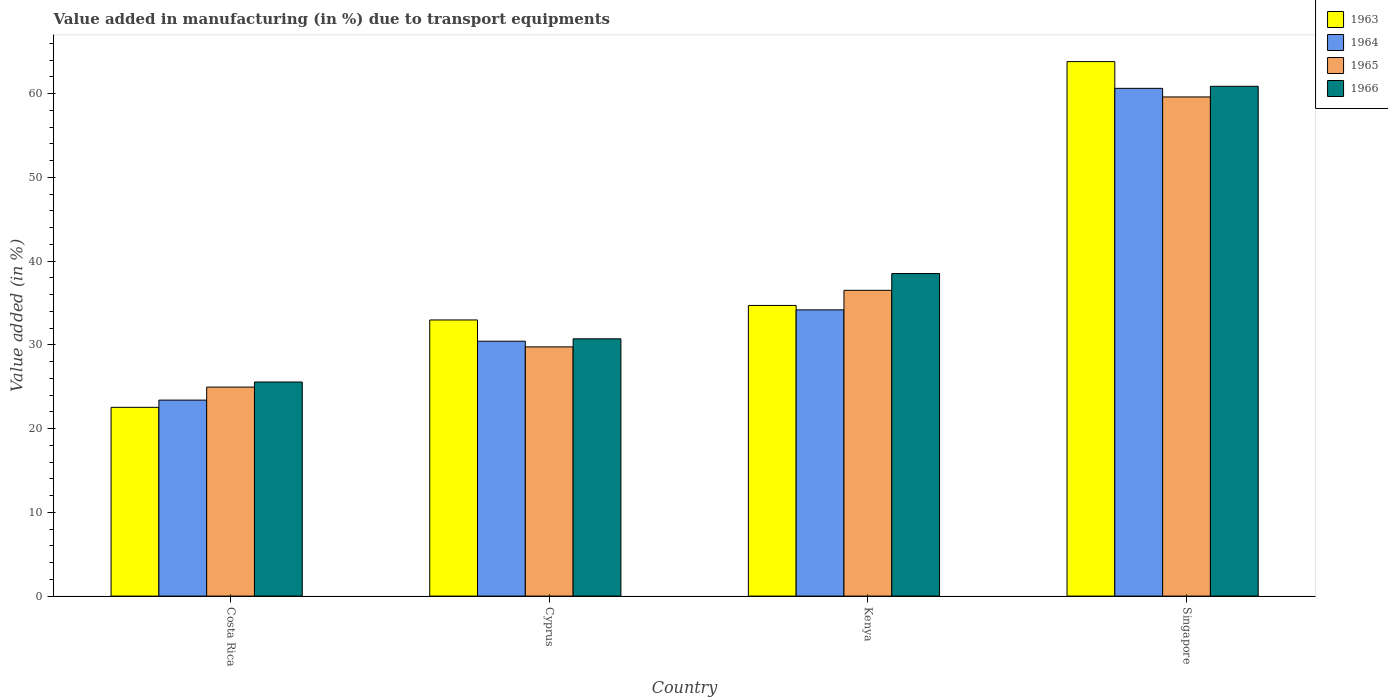How many groups of bars are there?
Make the answer very short. 4. Are the number of bars per tick equal to the number of legend labels?
Offer a terse response. Yes. Are the number of bars on each tick of the X-axis equal?
Offer a terse response. Yes. How many bars are there on the 1st tick from the left?
Your answer should be very brief. 4. What is the label of the 1st group of bars from the left?
Keep it short and to the point. Costa Rica. What is the percentage of value added in manufacturing due to transport equipments in 1964 in Costa Rica?
Offer a very short reply. 23.4. Across all countries, what is the maximum percentage of value added in manufacturing due to transport equipments in 1964?
Your answer should be very brief. 60.62. Across all countries, what is the minimum percentage of value added in manufacturing due to transport equipments in 1965?
Keep it short and to the point. 24.95. In which country was the percentage of value added in manufacturing due to transport equipments in 1965 maximum?
Offer a very short reply. Singapore. In which country was the percentage of value added in manufacturing due to transport equipments in 1966 minimum?
Give a very brief answer. Costa Rica. What is the total percentage of value added in manufacturing due to transport equipments in 1963 in the graph?
Your response must be concise. 154.01. What is the difference between the percentage of value added in manufacturing due to transport equipments in 1965 in Kenya and that in Singapore?
Give a very brief answer. -23.09. What is the difference between the percentage of value added in manufacturing due to transport equipments in 1964 in Cyprus and the percentage of value added in manufacturing due to transport equipments in 1966 in Costa Rica?
Provide a short and direct response. 4.87. What is the average percentage of value added in manufacturing due to transport equipments in 1965 per country?
Ensure brevity in your answer.  37.7. What is the difference between the percentage of value added in manufacturing due to transport equipments of/in 1965 and percentage of value added in manufacturing due to transport equipments of/in 1963 in Kenya?
Make the answer very short. 1.8. In how many countries, is the percentage of value added in manufacturing due to transport equipments in 1964 greater than 18 %?
Your answer should be compact. 4. What is the ratio of the percentage of value added in manufacturing due to transport equipments in 1965 in Cyprus to that in Kenya?
Make the answer very short. 0.82. Is the difference between the percentage of value added in manufacturing due to transport equipments in 1965 in Cyprus and Kenya greater than the difference between the percentage of value added in manufacturing due to transport equipments in 1963 in Cyprus and Kenya?
Make the answer very short. No. What is the difference between the highest and the second highest percentage of value added in manufacturing due to transport equipments in 1966?
Make the answer very short. 22.35. What is the difference between the highest and the lowest percentage of value added in manufacturing due to transport equipments in 1966?
Provide a short and direct response. 35.3. In how many countries, is the percentage of value added in manufacturing due to transport equipments in 1965 greater than the average percentage of value added in manufacturing due to transport equipments in 1965 taken over all countries?
Provide a short and direct response. 1. Is the sum of the percentage of value added in manufacturing due to transport equipments in 1963 in Costa Rica and Cyprus greater than the maximum percentage of value added in manufacturing due to transport equipments in 1964 across all countries?
Ensure brevity in your answer.  No. What does the 4th bar from the left in Kenya represents?
Your answer should be compact. 1966. What does the 3rd bar from the right in Costa Rica represents?
Your response must be concise. 1964. Is it the case that in every country, the sum of the percentage of value added in manufacturing due to transport equipments in 1963 and percentage of value added in manufacturing due to transport equipments in 1965 is greater than the percentage of value added in manufacturing due to transport equipments in 1964?
Provide a succinct answer. Yes. Are all the bars in the graph horizontal?
Offer a very short reply. No. Does the graph contain any zero values?
Ensure brevity in your answer.  No. Where does the legend appear in the graph?
Make the answer very short. Top right. How many legend labels are there?
Give a very brief answer. 4. How are the legend labels stacked?
Make the answer very short. Vertical. What is the title of the graph?
Keep it short and to the point. Value added in manufacturing (in %) due to transport equipments. What is the label or title of the X-axis?
Keep it short and to the point. Country. What is the label or title of the Y-axis?
Offer a very short reply. Value added (in %). What is the Value added (in %) in 1963 in Costa Rica?
Make the answer very short. 22.53. What is the Value added (in %) of 1964 in Costa Rica?
Provide a succinct answer. 23.4. What is the Value added (in %) in 1965 in Costa Rica?
Keep it short and to the point. 24.95. What is the Value added (in %) in 1966 in Costa Rica?
Your response must be concise. 25.56. What is the Value added (in %) in 1963 in Cyprus?
Your response must be concise. 32.97. What is the Value added (in %) of 1964 in Cyprus?
Make the answer very short. 30.43. What is the Value added (in %) of 1965 in Cyprus?
Provide a succinct answer. 29.75. What is the Value added (in %) in 1966 in Cyprus?
Ensure brevity in your answer.  30.72. What is the Value added (in %) of 1963 in Kenya?
Ensure brevity in your answer.  34.7. What is the Value added (in %) in 1964 in Kenya?
Your answer should be very brief. 34.17. What is the Value added (in %) in 1965 in Kenya?
Your answer should be very brief. 36.5. What is the Value added (in %) in 1966 in Kenya?
Your answer should be very brief. 38.51. What is the Value added (in %) of 1963 in Singapore?
Provide a short and direct response. 63.81. What is the Value added (in %) of 1964 in Singapore?
Offer a terse response. 60.62. What is the Value added (in %) in 1965 in Singapore?
Your answer should be very brief. 59.59. What is the Value added (in %) of 1966 in Singapore?
Keep it short and to the point. 60.86. Across all countries, what is the maximum Value added (in %) in 1963?
Your answer should be very brief. 63.81. Across all countries, what is the maximum Value added (in %) of 1964?
Your answer should be very brief. 60.62. Across all countries, what is the maximum Value added (in %) of 1965?
Your response must be concise. 59.59. Across all countries, what is the maximum Value added (in %) in 1966?
Provide a short and direct response. 60.86. Across all countries, what is the minimum Value added (in %) in 1963?
Make the answer very short. 22.53. Across all countries, what is the minimum Value added (in %) in 1964?
Keep it short and to the point. 23.4. Across all countries, what is the minimum Value added (in %) of 1965?
Offer a terse response. 24.95. Across all countries, what is the minimum Value added (in %) in 1966?
Offer a very short reply. 25.56. What is the total Value added (in %) of 1963 in the graph?
Offer a terse response. 154.01. What is the total Value added (in %) in 1964 in the graph?
Ensure brevity in your answer.  148.61. What is the total Value added (in %) of 1965 in the graph?
Your answer should be compact. 150.8. What is the total Value added (in %) in 1966 in the graph?
Ensure brevity in your answer.  155.64. What is the difference between the Value added (in %) in 1963 in Costa Rica and that in Cyprus?
Offer a terse response. -10.43. What is the difference between the Value added (in %) of 1964 in Costa Rica and that in Cyprus?
Provide a short and direct response. -7.03. What is the difference between the Value added (in %) in 1965 in Costa Rica and that in Cyprus?
Provide a succinct answer. -4.8. What is the difference between the Value added (in %) of 1966 in Costa Rica and that in Cyprus?
Your response must be concise. -5.16. What is the difference between the Value added (in %) in 1963 in Costa Rica and that in Kenya?
Provide a succinct answer. -12.17. What is the difference between the Value added (in %) in 1964 in Costa Rica and that in Kenya?
Offer a terse response. -10.77. What is the difference between the Value added (in %) in 1965 in Costa Rica and that in Kenya?
Your answer should be compact. -11.55. What is the difference between the Value added (in %) in 1966 in Costa Rica and that in Kenya?
Your answer should be very brief. -12.95. What is the difference between the Value added (in %) of 1963 in Costa Rica and that in Singapore?
Your answer should be very brief. -41.28. What is the difference between the Value added (in %) in 1964 in Costa Rica and that in Singapore?
Keep it short and to the point. -37.22. What is the difference between the Value added (in %) in 1965 in Costa Rica and that in Singapore?
Your response must be concise. -34.64. What is the difference between the Value added (in %) of 1966 in Costa Rica and that in Singapore?
Give a very brief answer. -35.3. What is the difference between the Value added (in %) in 1963 in Cyprus and that in Kenya?
Offer a terse response. -1.73. What is the difference between the Value added (in %) of 1964 in Cyprus and that in Kenya?
Give a very brief answer. -3.74. What is the difference between the Value added (in %) of 1965 in Cyprus and that in Kenya?
Keep it short and to the point. -6.75. What is the difference between the Value added (in %) in 1966 in Cyprus and that in Kenya?
Ensure brevity in your answer.  -7.79. What is the difference between the Value added (in %) of 1963 in Cyprus and that in Singapore?
Make the answer very short. -30.84. What is the difference between the Value added (in %) in 1964 in Cyprus and that in Singapore?
Your answer should be compact. -30.19. What is the difference between the Value added (in %) of 1965 in Cyprus and that in Singapore?
Give a very brief answer. -29.84. What is the difference between the Value added (in %) of 1966 in Cyprus and that in Singapore?
Keep it short and to the point. -30.14. What is the difference between the Value added (in %) in 1963 in Kenya and that in Singapore?
Keep it short and to the point. -29.11. What is the difference between the Value added (in %) in 1964 in Kenya and that in Singapore?
Keep it short and to the point. -26.45. What is the difference between the Value added (in %) in 1965 in Kenya and that in Singapore?
Your response must be concise. -23.09. What is the difference between the Value added (in %) of 1966 in Kenya and that in Singapore?
Offer a very short reply. -22.35. What is the difference between the Value added (in %) in 1963 in Costa Rica and the Value added (in %) in 1964 in Cyprus?
Offer a very short reply. -7.9. What is the difference between the Value added (in %) of 1963 in Costa Rica and the Value added (in %) of 1965 in Cyprus?
Provide a succinct answer. -7.22. What is the difference between the Value added (in %) of 1963 in Costa Rica and the Value added (in %) of 1966 in Cyprus?
Ensure brevity in your answer.  -8.18. What is the difference between the Value added (in %) of 1964 in Costa Rica and the Value added (in %) of 1965 in Cyprus?
Your answer should be compact. -6.36. What is the difference between the Value added (in %) in 1964 in Costa Rica and the Value added (in %) in 1966 in Cyprus?
Keep it short and to the point. -7.32. What is the difference between the Value added (in %) of 1965 in Costa Rica and the Value added (in %) of 1966 in Cyprus?
Provide a succinct answer. -5.77. What is the difference between the Value added (in %) in 1963 in Costa Rica and the Value added (in %) in 1964 in Kenya?
Give a very brief answer. -11.64. What is the difference between the Value added (in %) in 1963 in Costa Rica and the Value added (in %) in 1965 in Kenya?
Keep it short and to the point. -13.97. What is the difference between the Value added (in %) of 1963 in Costa Rica and the Value added (in %) of 1966 in Kenya?
Ensure brevity in your answer.  -15.97. What is the difference between the Value added (in %) in 1964 in Costa Rica and the Value added (in %) in 1965 in Kenya?
Keep it short and to the point. -13.11. What is the difference between the Value added (in %) in 1964 in Costa Rica and the Value added (in %) in 1966 in Kenya?
Offer a very short reply. -15.11. What is the difference between the Value added (in %) of 1965 in Costa Rica and the Value added (in %) of 1966 in Kenya?
Offer a terse response. -13.56. What is the difference between the Value added (in %) in 1963 in Costa Rica and the Value added (in %) in 1964 in Singapore?
Give a very brief answer. -38.08. What is the difference between the Value added (in %) of 1963 in Costa Rica and the Value added (in %) of 1965 in Singapore?
Give a very brief answer. -37.06. What is the difference between the Value added (in %) of 1963 in Costa Rica and the Value added (in %) of 1966 in Singapore?
Provide a short and direct response. -38.33. What is the difference between the Value added (in %) in 1964 in Costa Rica and the Value added (in %) in 1965 in Singapore?
Your answer should be very brief. -36.19. What is the difference between the Value added (in %) of 1964 in Costa Rica and the Value added (in %) of 1966 in Singapore?
Keep it short and to the point. -37.46. What is the difference between the Value added (in %) of 1965 in Costa Rica and the Value added (in %) of 1966 in Singapore?
Ensure brevity in your answer.  -35.91. What is the difference between the Value added (in %) of 1963 in Cyprus and the Value added (in %) of 1964 in Kenya?
Give a very brief answer. -1.2. What is the difference between the Value added (in %) in 1963 in Cyprus and the Value added (in %) in 1965 in Kenya?
Keep it short and to the point. -3.54. What is the difference between the Value added (in %) in 1963 in Cyprus and the Value added (in %) in 1966 in Kenya?
Ensure brevity in your answer.  -5.54. What is the difference between the Value added (in %) in 1964 in Cyprus and the Value added (in %) in 1965 in Kenya?
Your answer should be compact. -6.07. What is the difference between the Value added (in %) in 1964 in Cyprus and the Value added (in %) in 1966 in Kenya?
Your answer should be very brief. -8.08. What is the difference between the Value added (in %) in 1965 in Cyprus and the Value added (in %) in 1966 in Kenya?
Your answer should be very brief. -8.75. What is the difference between the Value added (in %) in 1963 in Cyprus and the Value added (in %) in 1964 in Singapore?
Make the answer very short. -27.65. What is the difference between the Value added (in %) of 1963 in Cyprus and the Value added (in %) of 1965 in Singapore?
Ensure brevity in your answer.  -26.62. What is the difference between the Value added (in %) in 1963 in Cyprus and the Value added (in %) in 1966 in Singapore?
Ensure brevity in your answer.  -27.89. What is the difference between the Value added (in %) in 1964 in Cyprus and the Value added (in %) in 1965 in Singapore?
Keep it short and to the point. -29.16. What is the difference between the Value added (in %) of 1964 in Cyprus and the Value added (in %) of 1966 in Singapore?
Ensure brevity in your answer.  -30.43. What is the difference between the Value added (in %) of 1965 in Cyprus and the Value added (in %) of 1966 in Singapore?
Provide a short and direct response. -31.11. What is the difference between the Value added (in %) of 1963 in Kenya and the Value added (in %) of 1964 in Singapore?
Keep it short and to the point. -25.92. What is the difference between the Value added (in %) of 1963 in Kenya and the Value added (in %) of 1965 in Singapore?
Provide a short and direct response. -24.89. What is the difference between the Value added (in %) of 1963 in Kenya and the Value added (in %) of 1966 in Singapore?
Give a very brief answer. -26.16. What is the difference between the Value added (in %) of 1964 in Kenya and the Value added (in %) of 1965 in Singapore?
Provide a succinct answer. -25.42. What is the difference between the Value added (in %) in 1964 in Kenya and the Value added (in %) in 1966 in Singapore?
Give a very brief answer. -26.69. What is the difference between the Value added (in %) of 1965 in Kenya and the Value added (in %) of 1966 in Singapore?
Keep it short and to the point. -24.36. What is the average Value added (in %) in 1963 per country?
Your response must be concise. 38.5. What is the average Value added (in %) of 1964 per country?
Ensure brevity in your answer.  37.15. What is the average Value added (in %) in 1965 per country?
Ensure brevity in your answer.  37.7. What is the average Value added (in %) in 1966 per country?
Offer a terse response. 38.91. What is the difference between the Value added (in %) of 1963 and Value added (in %) of 1964 in Costa Rica?
Make the answer very short. -0.86. What is the difference between the Value added (in %) of 1963 and Value added (in %) of 1965 in Costa Rica?
Your response must be concise. -2.42. What is the difference between the Value added (in %) in 1963 and Value added (in %) in 1966 in Costa Rica?
Make the answer very short. -3.03. What is the difference between the Value added (in %) in 1964 and Value added (in %) in 1965 in Costa Rica?
Give a very brief answer. -1.55. What is the difference between the Value added (in %) of 1964 and Value added (in %) of 1966 in Costa Rica?
Provide a short and direct response. -2.16. What is the difference between the Value added (in %) in 1965 and Value added (in %) in 1966 in Costa Rica?
Your answer should be very brief. -0.61. What is the difference between the Value added (in %) of 1963 and Value added (in %) of 1964 in Cyprus?
Make the answer very short. 2.54. What is the difference between the Value added (in %) of 1963 and Value added (in %) of 1965 in Cyprus?
Offer a very short reply. 3.21. What is the difference between the Value added (in %) in 1963 and Value added (in %) in 1966 in Cyprus?
Give a very brief answer. 2.25. What is the difference between the Value added (in %) in 1964 and Value added (in %) in 1965 in Cyprus?
Offer a terse response. 0.68. What is the difference between the Value added (in %) in 1964 and Value added (in %) in 1966 in Cyprus?
Your answer should be very brief. -0.29. What is the difference between the Value added (in %) of 1965 and Value added (in %) of 1966 in Cyprus?
Give a very brief answer. -0.96. What is the difference between the Value added (in %) in 1963 and Value added (in %) in 1964 in Kenya?
Your response must be concise. 0.53. What is the difference between the Value added (in %) in 1963 and Value added (in %) in 1965 in Kenya?
Your answer should be very brief. -1.8. What is the difference between the Value added (in %) in 1963 and Value added (in %) in 1966 in Kenya?
Your response must be concise. -3.81. What is the difference between the Value added (in %) of 1964 and Value added (in %) of 1965 in Kenya?
Your answer should be compact. -2.33. What is the difference between the Value added (in %) of 1964 and Value added (in %) of 1966 in Kenya?
Provide a succinct answer. -4.34. What is the difference between the Value added (in %) of 1965 and Value added (in %) of 1966 in Kenya?
Give a very brief answer. -2. What is the difference between the Value added (in %) of 1963 and Value added (in %) of 1964 in Singapore?
Ensure brevity in your answer.  3.19. What is the difference between the Value added (in %) of 1963 and Value added (in %) of 1965 in Singapore?
Provide a succinct answer. 4.22. What is the difference between the Value added (in %) of 1963 and Value added (in %) of 1966 in Singapore?
Offer a terse response. 2.95. What is the difference between the Value added (in %) of 1964 and Value added (in %) of 1965 in Singapore?
Keep it short and to the point. 1.03. What is the difference between the Value added (in %) of 1964 and Value added (in %) of 1966 in Singapore?
Your response must be concise. -0.24. What is the difference between the Value added (in %) in 1965 and Value added (in %) in 1966 in Singapore?
Make the answer very short. -1.27. What is the ratio of the Value added (in %) in 1963 in Costa Rica to that in Cyprus?
Your answer should be compact. 0.68. What is the ratio of the Value added (in %) of 1964 in Costa Rica to that in Cyprus?
Your answer should be compact. 0.77. What is the ratio of the Value added (in %) in 1965 in Costa Rica to that in Cyprus?
Your response must be concise. 0.84. What is the ratio of the Value added (in %) of 1966 in Costa Rica to that in Cyprus?
Offer a very short reply. 0.83. What is the ratio of the Value added (in %) of 1963 in Costa Rica to that in Kenya?
Give a very brief answer. 0.65. What is the ratio of the Value added (in %) of 1964 in Costa Rica to that in Kenya?
Your answer should be very brief. 0.68. What is the ratio of the Value added (in %) in 1965 in Costa Rica to that in Kenya?
Provide a short and direct response. 0.68. What is the ratio of the Value added (in %) of 1966 in Costa Rica to that in Kenya?
Your answer should be compact. 0.66. What is the ratio of the Value added (in %) in 1963 in Costa Rica to that in Singapore?
Provide a short and direct response. 0.35. What is the ratio of the Value added (in %) of 1964 in Costa Rica to that in Singapore?
Offer a very short reply. 0.39. What is the ratio of the Value added (in %) in 1965 in Costa Rica to that in Singapore?
Offer a very short reply. 0.42. What is the ratio of the Value added (in %) in 1966 in Costa Rica to that in Singapore?
Your answer should be very brief. 0.42. What is the ratio of the Value added (in %) of 1963 in Cyprus to that in Kenya?
Make the answer very short. 0.95. What is the ratio of the Value added (in %) of 1964 in Cyprus to that in Kenya?
Ensure brevity in your answer.  0.89. What is the ratio of the Value added (in %) of 1965 in Cyprus to that in Kenya?
Provide a succinct answer. 0.82. What is the ratio of the Value added (in %) of 1966 in Cyprus to that in Kenya?
Keep it short and to the point. 0.8. What is the ratio of the Value added (in %) of 1963 in Cyprus to that in Singapore?
Your answer should be compact. 0.52. What is the ratio of the Value added (in %) in 1964 in Cyprus to that in Singapore?
Your response must be concise. 0.5. What is the ratio of the Value added (in %) in 1965 in Cyprus to that in Singapore?
Your answer should be compact. 0.5. What is the ratio of the Value added (in %) in 1966 in Cyprus to that in Singapore?
Your answer should be very brief. 0.5. What is the ratio of the Value added (in %) of 1963 in Kenya to that in Singapore?
Provide a short and direct response. 0.54. What is the ratio of the Value added (in %) of 1964 in Kenya to that in Singapore?
Ensure brevity in your answer.  0.56. What is the ratio of the Value added (in %) of 1965 in Kenya to that in Singapore?
Ensure brevity in your answer.  0.61. What is the ratio of the Value added (in %) in 1966 in Kenya to that in Singapore?
Make the answer very short. 0.63. What is the difference between the highest and the second highest Value added (in %) in 1963?
Make the answer very short. 29.11. What is the difference between the highest and the second highest Value added (in %) in 1964?
Ensure brevity in your answer.  26.45. What is the difference between the highest and the second highest Value added (in %) of 1965?
Ensure brevity in your answer.  23.09. What is the difference between the highest and the second highest Value added (in %) of 1966?
Give a very brief answer. 22.35. What is the difference between the highest and the lowest Value added (in %) in 1963?
Make the answer very short. 41.28. What is the difference between the highest and the lowest Value added (in %) of 1964?
Your answer should be very brief. 37.22. What is the difference between the highest and the lowest Value added (in %) of 1965?
Ensure brevity in your answer.  34.64. What is the difference between the highest and the lowest Value added (in %) in 1966?
Offer a terse response. 35.3. 